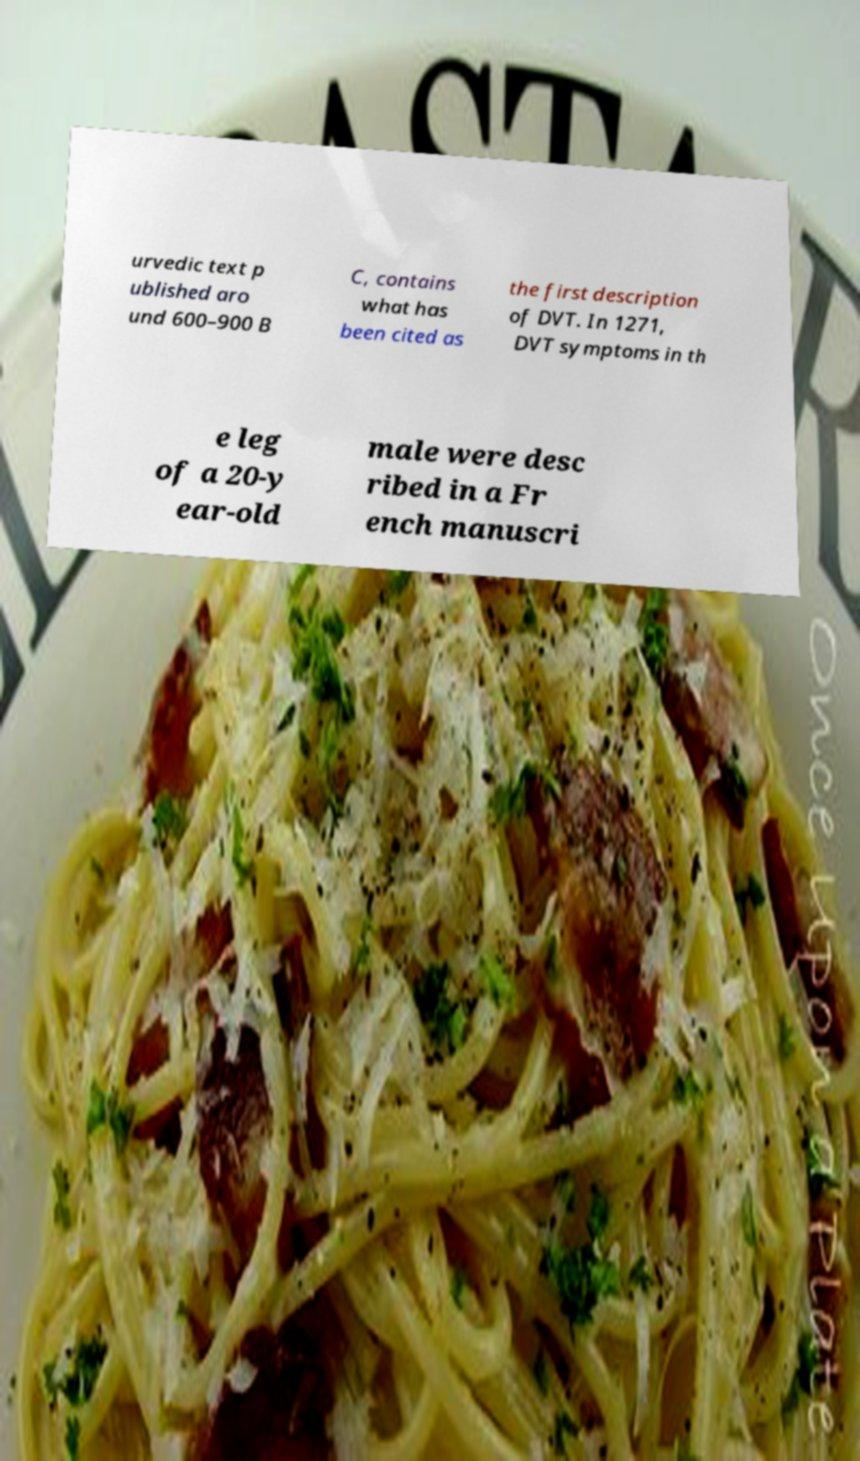For documentation purposes, I need the text within this image transcribed. Could you provide that? urvedic text p ublished aro und 600–900 B C, contains what has been cited as the first description of DVT. In 1271, DVT symptoms in th e leg of a 20-y ear-old male were desc ribed in a Fr ench manuscri 